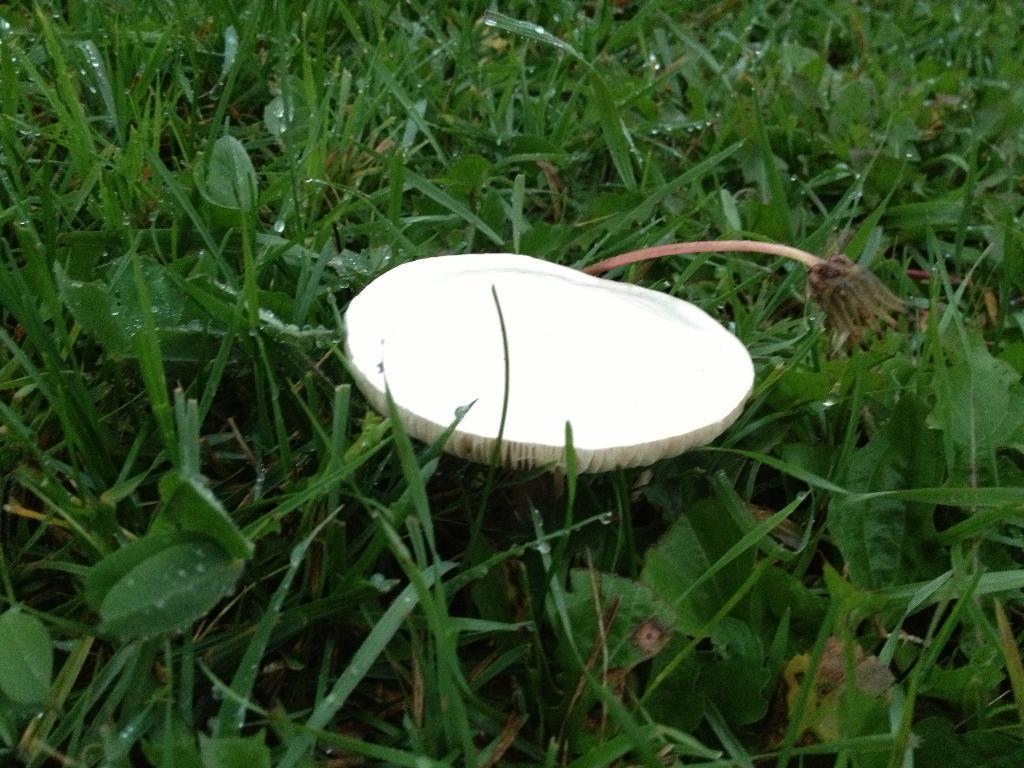Describe this image in one or two sentences. This image is taken outdoors. At the bottom of the image there is a ground with grass and green leaves on it. In the middle of the image there is a mushroom which is white in color. 